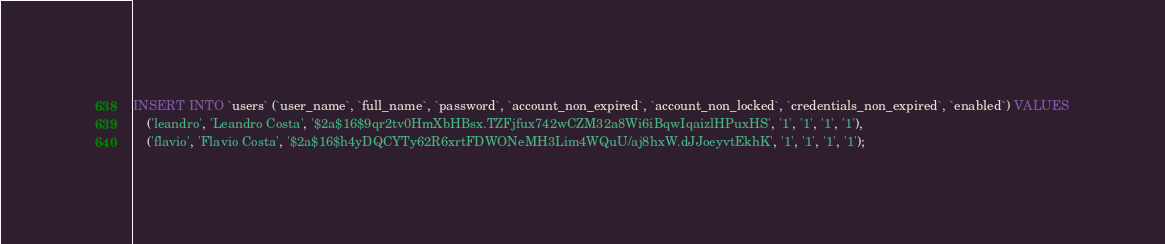Convert code to text. <code><loc_0><loc_0><loc_500><loc_500><_SQL_>INSERT INTO `users` (`user_name`, `full_name`, `password`, `account_non_expired`, `account_non_locked`, `credentials_non_expired`, `enabled`) VALUES
	('leandro', 'Leandro Costa', '$2a$16$9qr2tv0HmXbHBsx.TZFjfux742wCZM32a8Wi6iBqwIqaizlHPuxHS', '1', '1', '1', '1'),
	('flavio', 'Flavio Costa', '$2a$16$h4yDQCYTy62R6xrtFDWONeMH3Lim4WQuU/aj8hxW.dJJoeyvtEkhK', '1', '1', '1', '1');</code> 